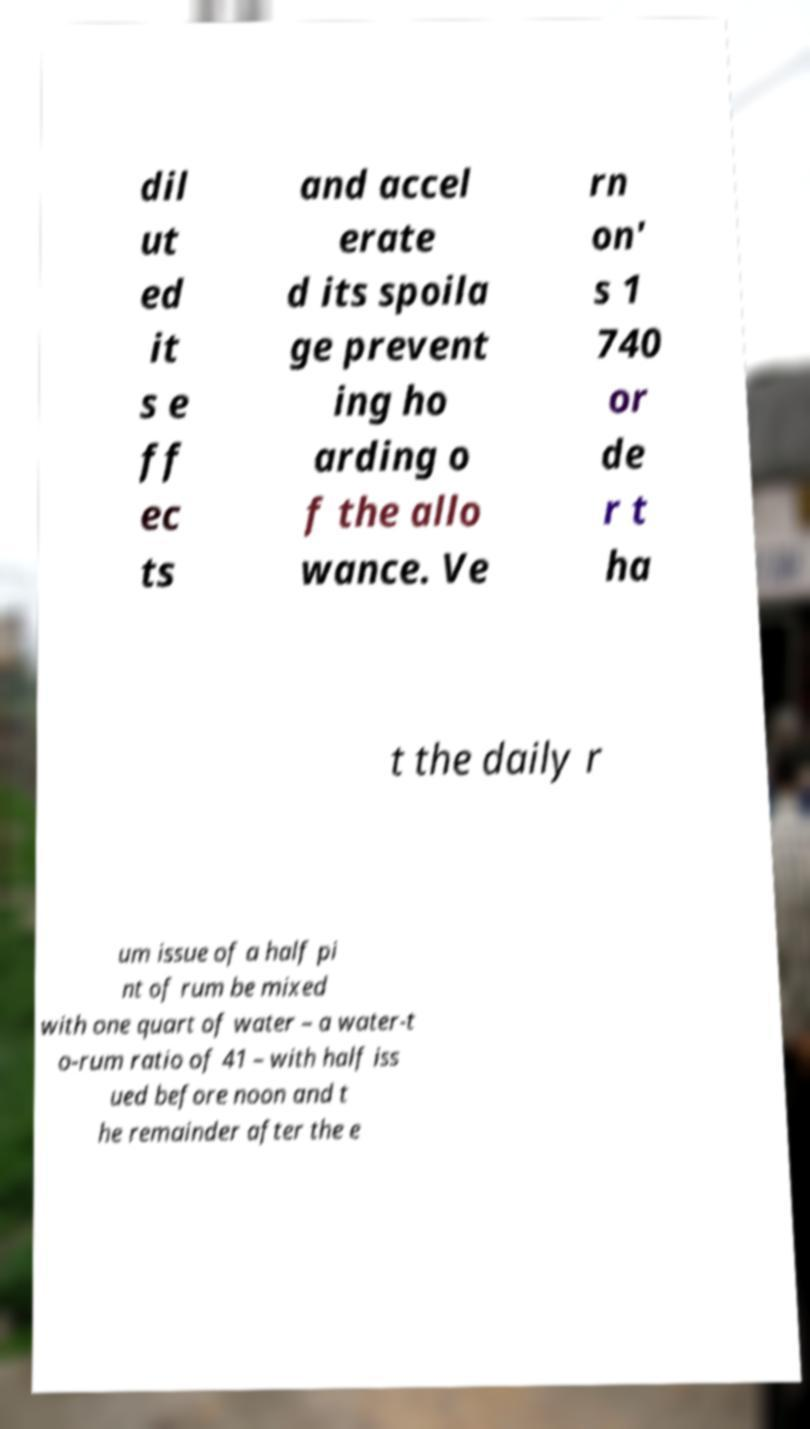I need the written content from this picture converted into text. Can you do that? dil ut ed it s e ff ec ts and accel erate d its spoila ge prevent ing ho arding o f the allo wance. Ve rn on' s 1 740 or de r t ha t the daily r um issue of a half pi nt of rum be mixed with one quart of water – a water-t o-rum ratio of 41 – with half iss ued before noon and t he remainder after the e 